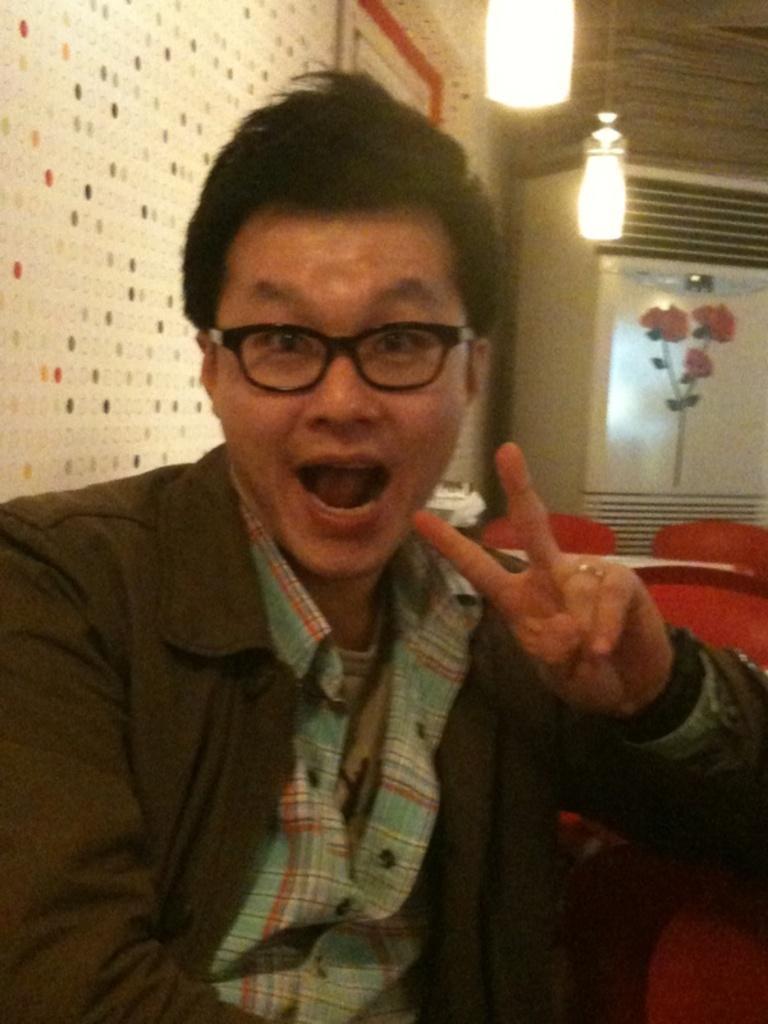Describe this image in one or two sentences. In this image we can see a person sitting, behind him we can see some chairs and a table, on the left side of the image we can see the wall, in the background it looks like cupboard and there are lights. 